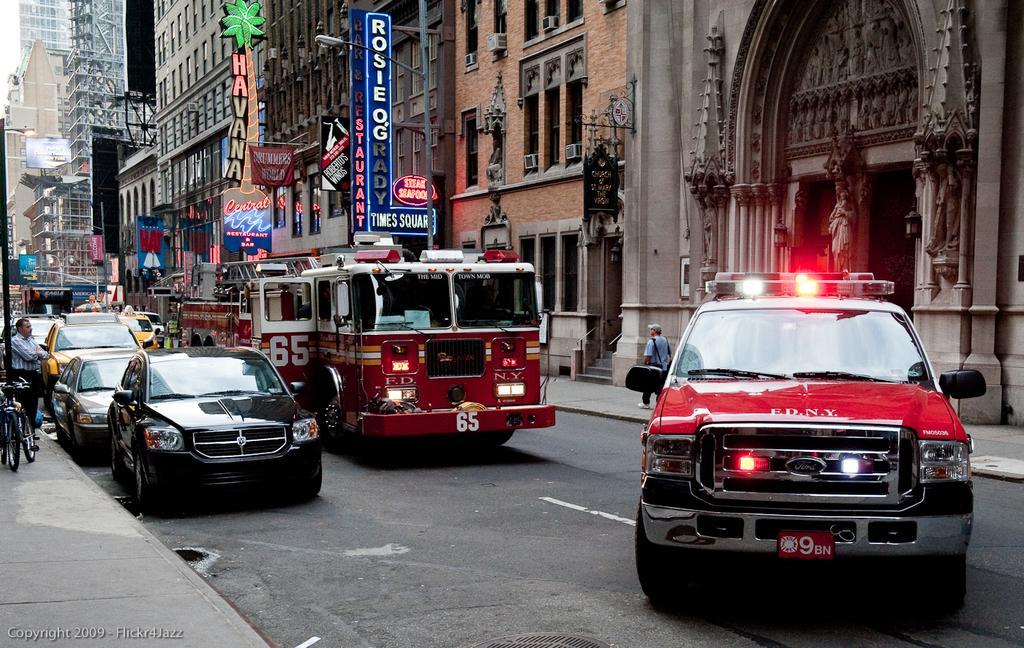How would you summarize this image in a sentence or two? In this image I can see a car which is red and black in color on the road and I can see few other cars and a fire engine which is maroon in color on the road. I can see few persons standing on the sidewalk, few bicycles and a black colored pole on the side walk. In the background I can see few buildings and few boards. 